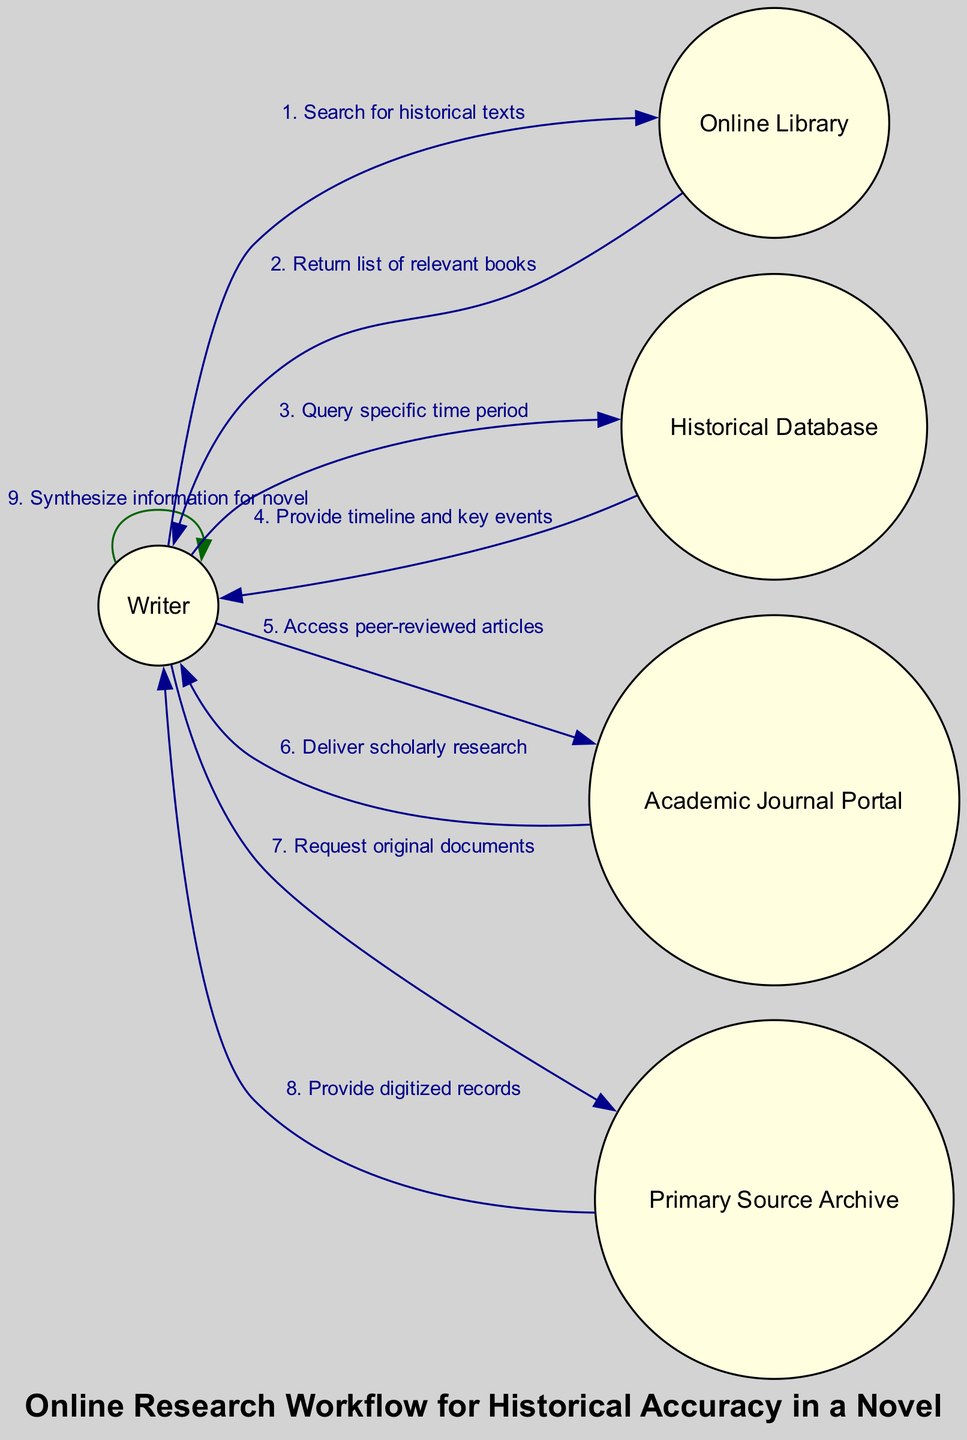What is the first action taken by the Writer? The diagram indicates that the first action is "Search for historical texts," where the Writer initiates the process by querying the Online Library.
Answer: Search for historical texts How many actors are present in the diagram? By counting the unique actors listed in the diagram, we see there are five: Writer, Online Library, Historical Database, Academic Journal Portal, and Primary Source Archive.
Answer: 5 What action is taken after the Writer queries the Historical Database? Following the query, the Historical Database provides a response, specifically the timeline and key events back to the Writer.
Answer: Provide timeline and key events Which nodes are involved in the final action of synthesizing information? The final action, "Synthesize information for novel," involves the Writer synthesizing the information they gathered from the various sources, indicating a self-referential action back to the Writer.
Answer: Writer How does the action flow from the Online Library to the Writer? The action flow shows that after the Writer searches for historical texts, the Online Library returns a list of relevant books, which constitutes a direct feedback loop in the sequence.
Answer: Return list of relevant books What is the last step in the online research workflow? The last step, as shown, involves the Writer synthesizing the collected information into their novel, concluding the entire process in the diagram.
Answer: Synthesize information for novel What type of documents does the Writer request from the Primary Source Archive? The diagram reveals that the Writer specifically requests "original documents" from the Primary Source Archive as part of their research process.
Answer: Original documents How many edges represent actions between the nodes? To determine the number of edges, we can count the actions listed between each of the nodes, which totals to eight actions according to the sequence provided in the diagram.
Answer: 8 What is the second node that the Writer interacts with after the Online Library? The second node interacted with by the Writer, after receiving the response from the Online Library, is the Historical Database, where the Writer conducts a query specific to a time period.
Answer: Historical Database 